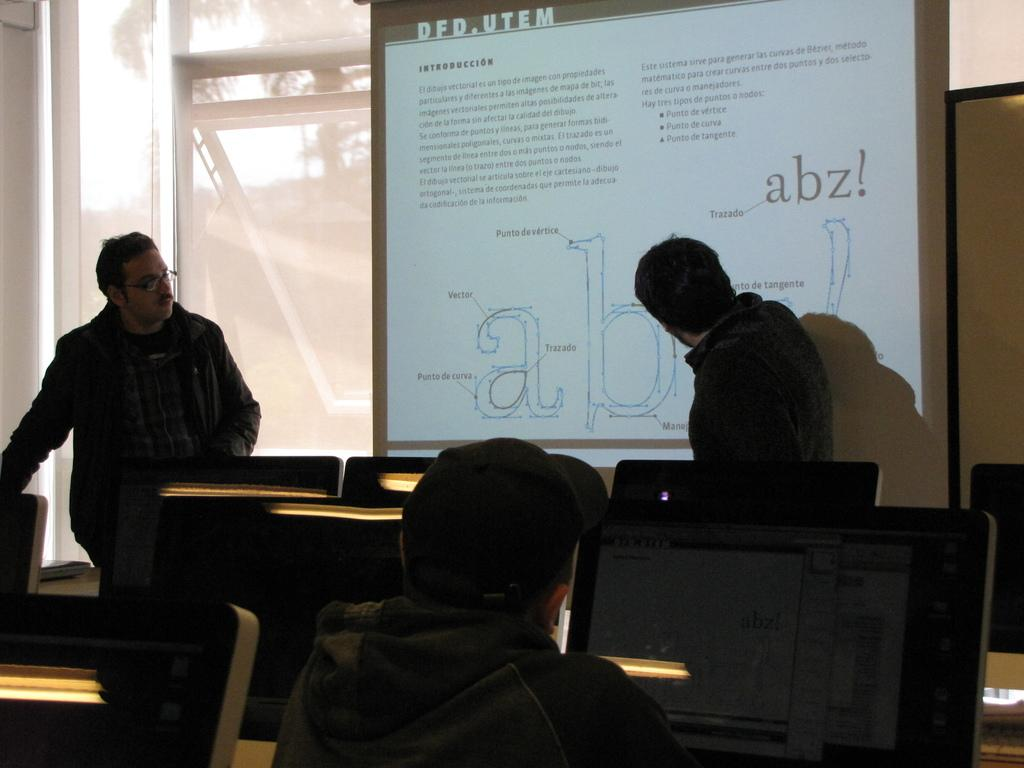How many people are in the image? There are three persons in the image. What can be seen on the tables in the image? There are monitors on tables in the image. What is displayed on the screen in the image? There is a screen with text in the image. What type of structure is visible in the image? There is a wall visible in the image. What allows natural light to enter the room in the image? There are windows in the image. What is the design of the scale in the image? There is no scale present in the image. What is the opinion of the person on the left regarding the text on the screen? The image does not provide any information about the person's opinions, so it cannot be determined from the image. 